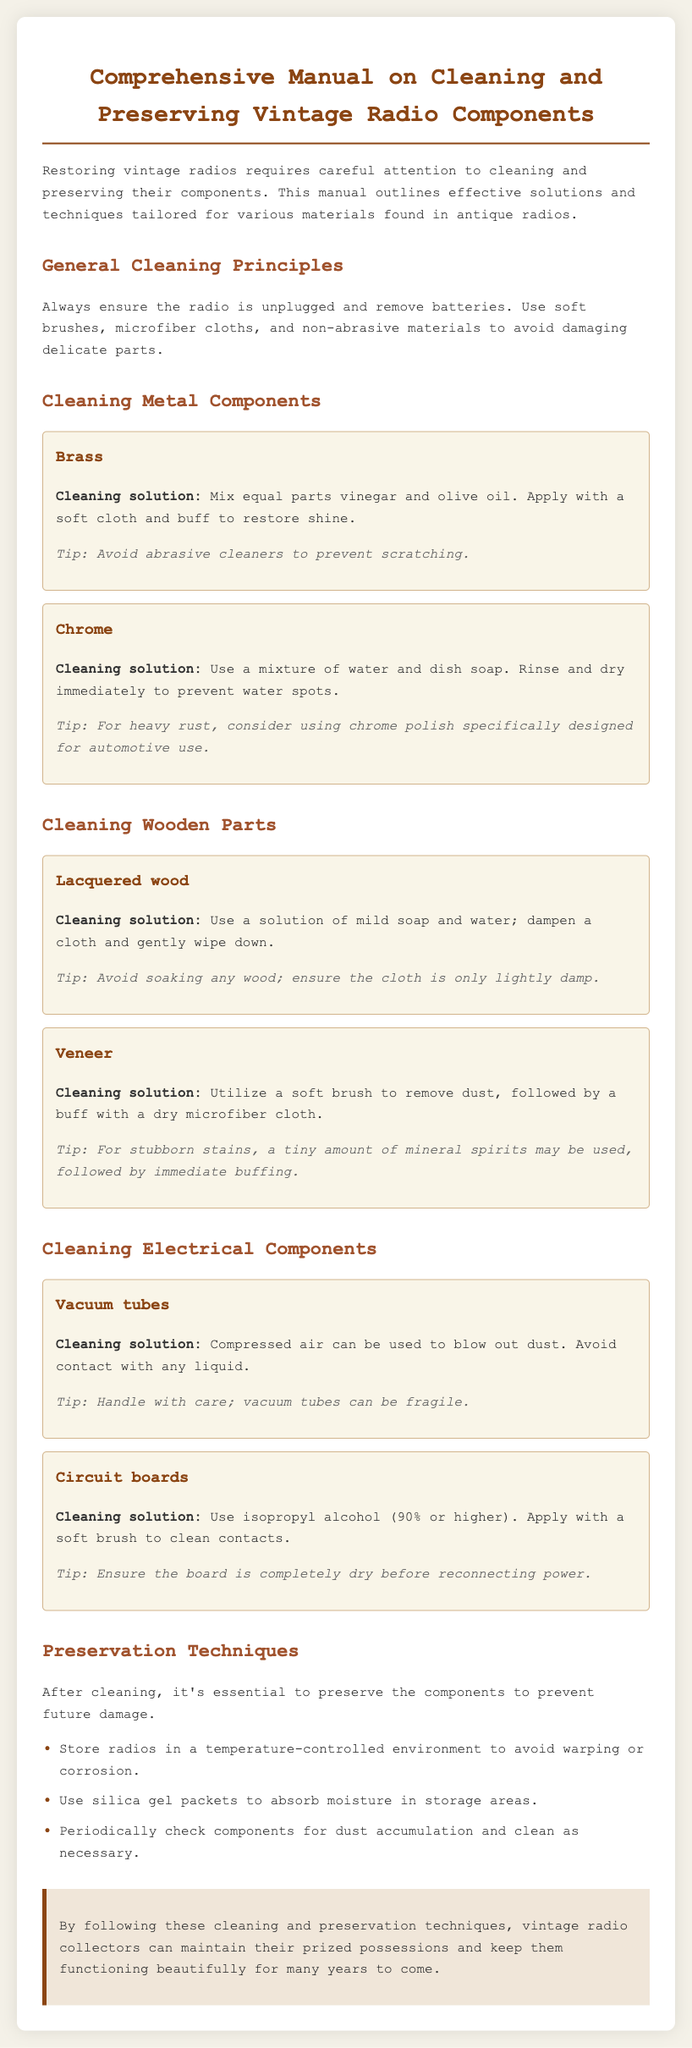what is the cleaning solution for brass? The cleaning solution for brass is a mixture of equal parts vinegar and olive oil.
Answer: vinegar and olive oil how should lacquered wood be cleaned? Lacquered wood should be cleaned with a solution of mild soap and water, dampening a cloth and gently wiping down.
Answer: mild soap and water what is used to clean vacuum tubes? Compressed air is used to blow out dust from vacuum tubes.
Answer: Compressed air which type of wood requires the use of mineral spirits for stubborn stains? Veneer requires the use of a tiny amount of mineral spirits for stubborn stains.
Answer: Veneer what is advised to store in the environment of the radios? Silica gel packets are advised to absorb moisture in storage areas.
Answer: silica gel packets what percentage of isopropyl alcohol should be used on circuit boards? Isopropyl alcohol (90% or higher) should be used on circuit boards.
Answer: 90% how often should components be checked for dust accumulation? Components should be checked periodically for dust accumulation.
Answer: periodically what should be avoided when cleaning chrome? It is advised to avoid water spots by rinsing and drying immediately.
Answer: water spots what is the primary focus of the manual? The primary focus of the manual is on cleaning and preserving vintage radio components.
Answer: cleaning and preserving vintage radio components 